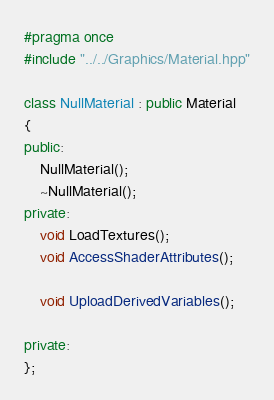Convert code to text. <code><loc_0><loc_0><loc_500><loc_500><_C++_>#pragma once
#include "../../Graphics/Material.hpp"

class NullMaterial : public Material
{
public:
	NullMaterial();
	~NullMaterial();
private:
	void LoadTextures();
	void AccessShaderAttributes();

	void UploadDerivedVariables();

private:
};

</code> 